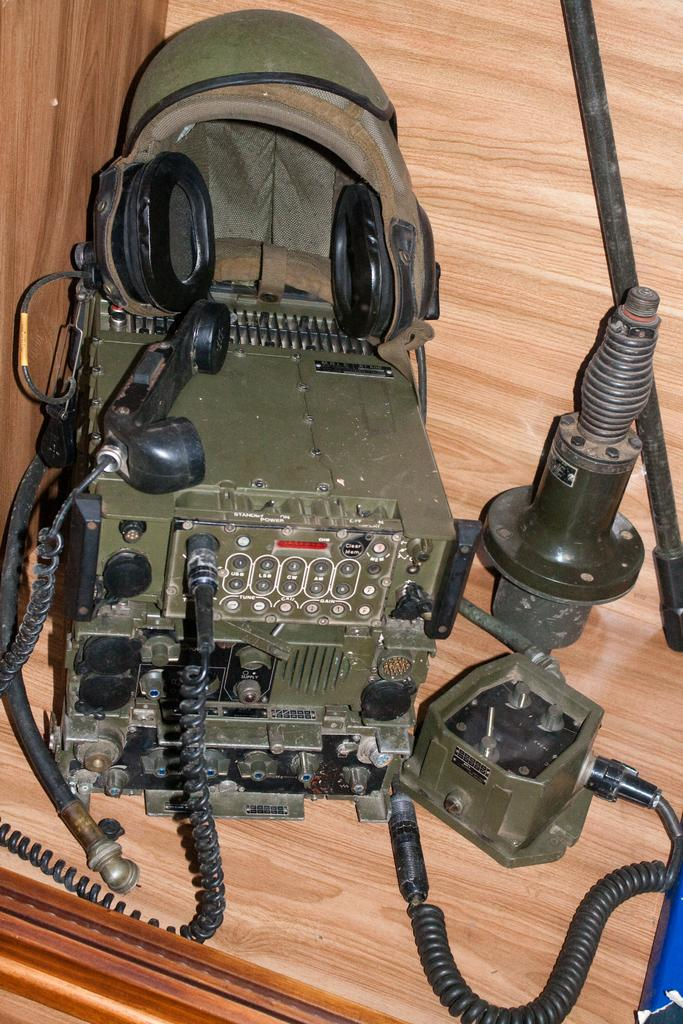What type of communication device is present in the image? There is a telephone in the image. What other electronic device can be seen in the image? There is an electronic device in the image. What material is used to make the metal object in the image? The metal object in the image is made of metal. What type of protective gear is present in the image? There is a helmet in the image. Where are the objects located in the image? The objects are on a platform. What is on the right side of the image? There is a pole on the right side of the image. How many eggs are being cooked on the pole in the image? There are no eggs present in the image, and the pole is not used for cooking. What type of smoke can be seen coming from the electronic device in the image? There is no smoke visible in the image, and the electronic device is not producing any smoke. 